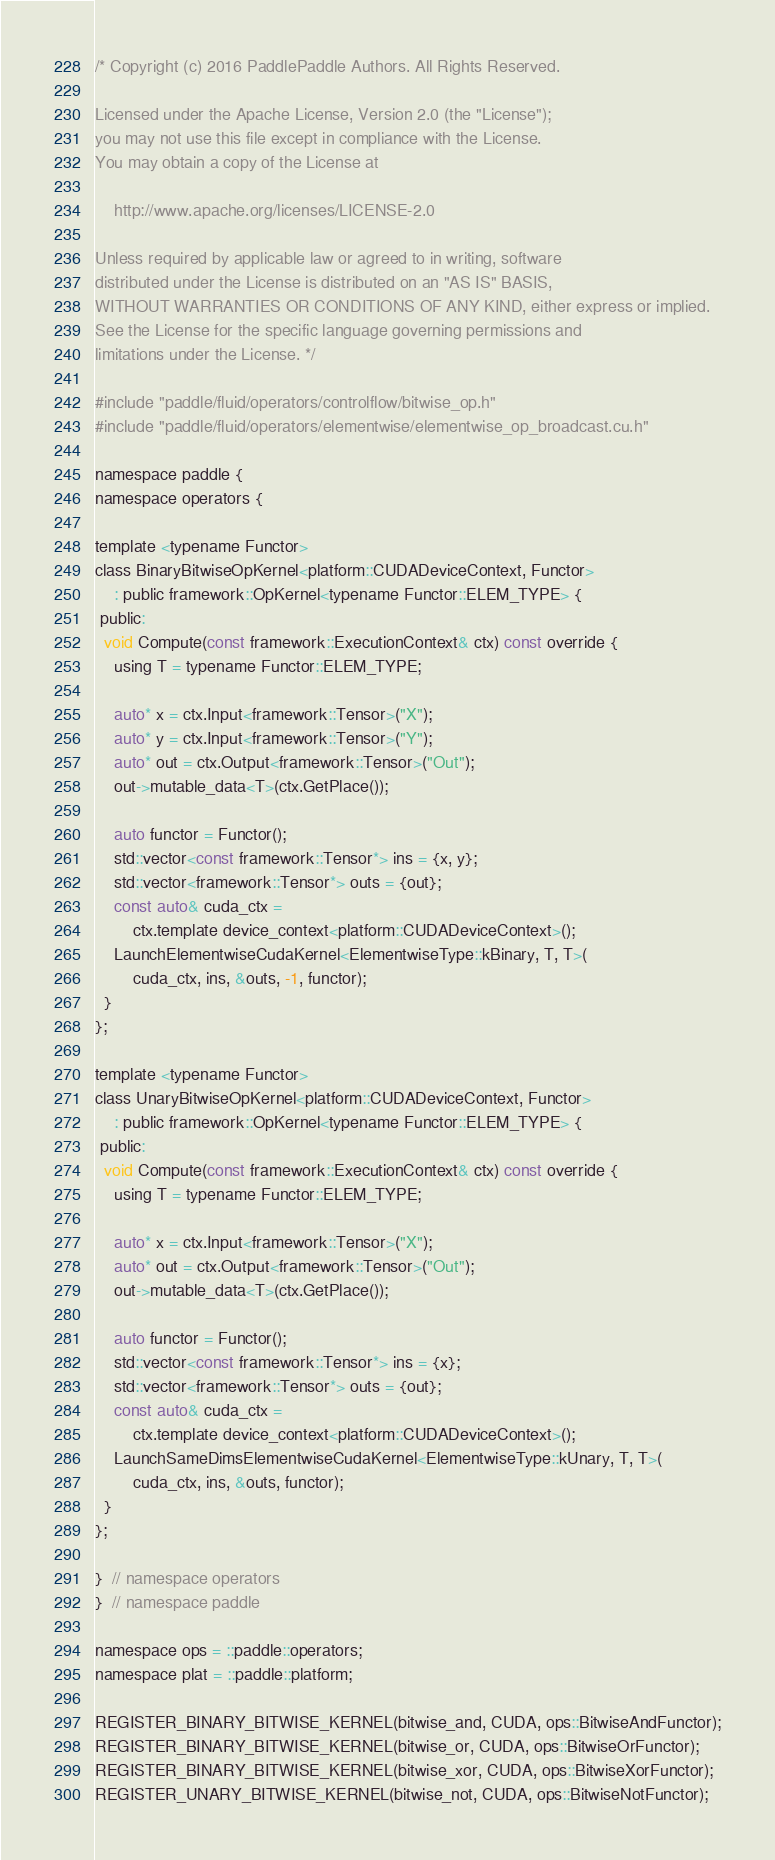Convert code to text. <code><loc_0><loc_0><loc_500><loc_500><_Cuda_>/* Copyright (c) 2016 PaddlePaddle Authors. All Rights Reserved.

Licensed under the Apache License, Version 2.0 (the "License");
you may not use this file except in compliance with the License.
You may obtain a copy of the License at

    http://www.apache.org/licenses/LICENSE-2.0

Unless required by applicable law or agreed to in writing, software
distributed under the License is distributed on an "AS IS" BASIS,
WITHOUT WARRANTIES OR CONDITIONS OF ANY KIND, either express or implied.
See the License for the specific language governing permissions and
limitations under the License. */

#include "paddle/fluid/operators/controlflow/bitwise_op.h"
#include "paddle/fluid/operators/elementwise/elementwise_op_broadcast.cu.h"

namespace paddle {
namespace operators {

template <typename Functor>
class BinaryBitwiseOpKernel<platform::CUDADeviceContext, Functor>
    : public framework::OpKernel<typename Functor::ELEM_TYPE> {
 public:
  void Compute(const framework::ExecutionContext& ctx) const override {
    using T = typename Functor::ELEM_TYPE;

    auto* x = ctx.Input<framework::Tensor>("X");
    auto* y = ctx.Input<framework::Tensor>("Y");
    auto* out = ctx.Output<framework::Tensor>("Out");
    out->mutable_data<T>(ctx.GetPlace());

    auto functor = Functor();
    std::vector<const framework::Tensor*> ins = {x, y};
    std::vector<framework::Tensor*> outs = {out};
    const auto& cuda_ctx =
        ctx.template device_context<platform::CUDADeviceContext>();
    LaunchElementwiseCudaKernel<ElementwiseType::kBinary, T, T>(
        cuda_ctx, ins, &outs, -1, functor);
  }
};

template <typename Functor>
class UnaryBitwiseOpKernel<platform::CUDADeviceContext, Functor>
    : public framework::OpKernel<typename Functor::ELEM_TYPE> {
 public:
  void Compute(const framework::ExecutionContext& ctx) const override {
    using T = typename Functor::ELEM_TYPE;

    auto* x = ctx.Input<framework::Tensor>("X");
    auto* out = ctx.Output<framework::Tensor>("Out");
    out->mutable_data<T>(ctx.GetPlace());

    auto functor = Functor();
    std::vector<const framework::Tensor*> ins = {x};
    std::vector<framework::Tensor*> outs = {out};
    const auto& cuda_ctx =
        ctx.template device_context<platform::CUDADeviceContext>();
    LaunchSameDimsElementwiseCudaKernel<ElementwiseType::kUnary, T, T>(
        cuda_ctx, ins, &outs, functor);
  }
};

}  // namespace operators
}  // namespace paddle

namespace ops = ::paddle::operators;
namespace plat = ::paddle::platform;

REGISTER_BINARY_BITWISE_KERNEL(bitwise_and, CUDA, ops::BitwiseAndFunctor);
REGISTER_BINARY_BITWISE_KERNEL(bitwise_or, CUDA, ops::BitwiseOrFunctor);
REGISTER_BINARY_BITWISE_KERNEL(bitwise_xor, CUDA, ops::BitwiseXorFunctor);
REGISTER_UNARY_BITWISE_KERNEL(bitwise_not, CUDA, ops::BitwiseNotFunctor);
</code> 